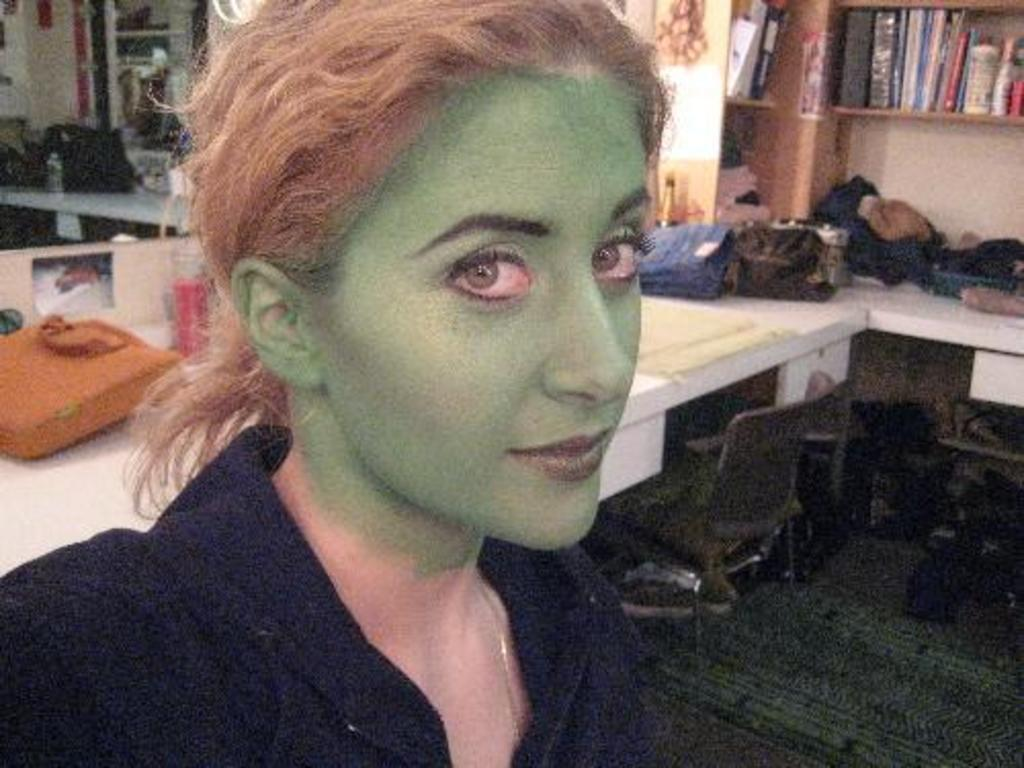Who is present in the image? There is a woman in the image. What is the woman's expression? The woman is smiling. What can be seen in the background of the image? There are bottles, bags, books in a rack, and a chair in the background of the image. What type of goose is depicted in the image? There is no goose present in the image. What action is the woman performing in the image? The provided facts do not mention any specific action the woman is performing; she is simply smiling. 